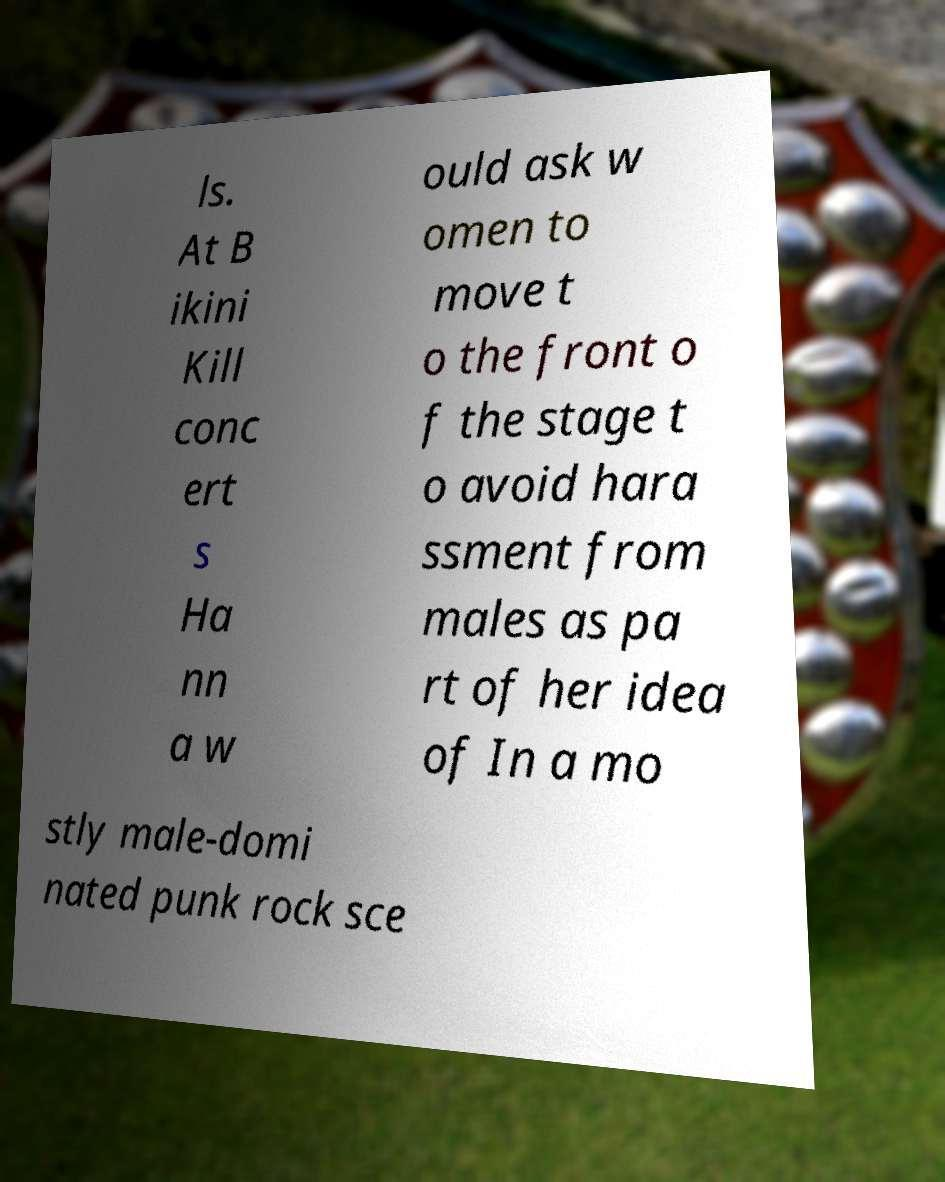What messages or text are displayed in this image? I need them in a readable, typed format. ls. At B ikini Kill conc ert s Ha nn a w ould ask w omen to move t o the front o f the stage t o avoid hara ssment from males as pa rt of her idea of In a mo stly male-domi nated punk rock sce 